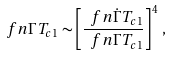<formula> <loc_0><loc_0><loc_500><loc_500>\ f n { \Gamma } { T _ { c 1 } } \sim \left [ \frac { \ f n { \dot { \Gamma } } { T _ { c 1 } } } { \ f n { \Gamma } { T _ { c 1 } } } \right ] ^ { 4 } \, ,</formula> 